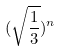Convert formula to latex. <formula><loc_0><loc_0><loc_500><loc_500>( \sqrt { \frac { 1 } { 3 } } ) ^ { n }</formula> 